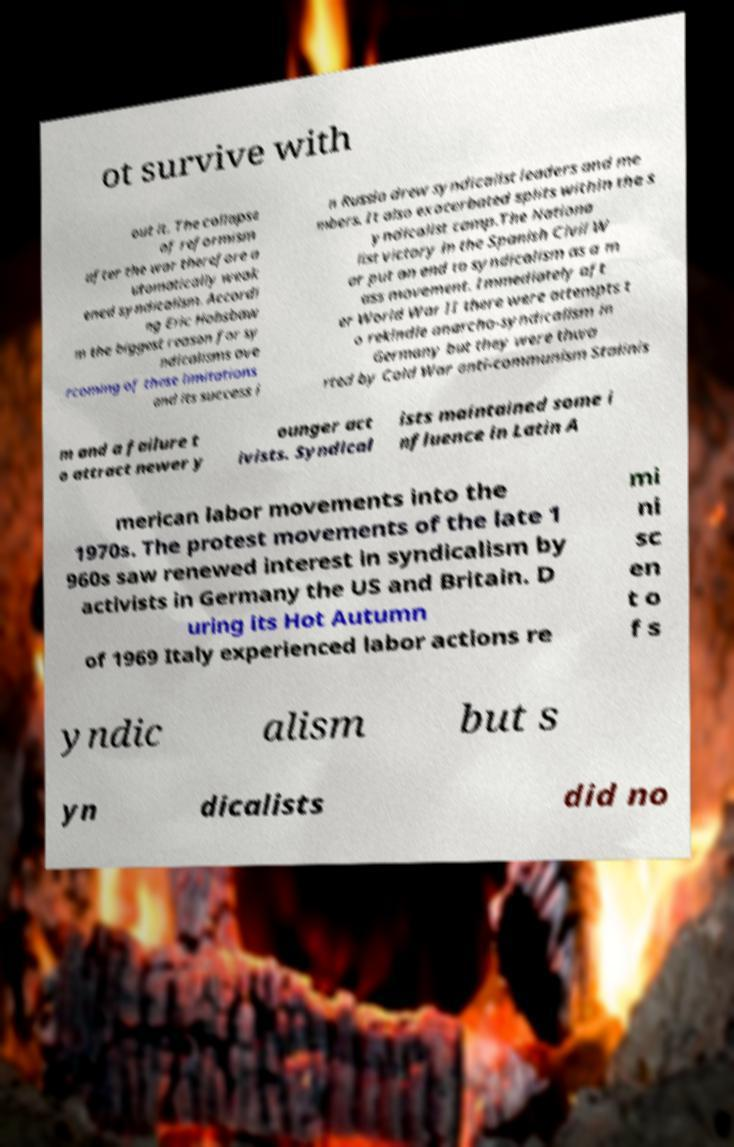There's text embedded in this image that I need extracted. Can you transcribe it verbatim? ot survive with out it. The collapse of reformism after the war therefore a utomatically weak ened syndicalism. Accordi ng Eric Hobsbaw m the biggest reason for sy ndicalisms ove rcoming of these limitations and its success i n Russia drew syndicalist leaders and me mbers. It also exacerbated splits within the s yndicalist camp.The Nationa list victory in the Spanish Civil W ar put an end to syndicalism as a m ass movement. Immediately aft er World War II there were attempts t o rekindle anarcho-syndicalism in Germany but they were thwa rted by Cold War anti-communism Stalinis m and a failure t o attract newer y ounger act ivists. Syndical ists maintained some i nfluence in Latin A merican labor movements into the 1970s. The protest movements of the late 1 960s saw renewed interest in syndicalism by activists in Germany the US and Britain. D uring its Hot Autumn of 1969 Italy experienced labor actions re mi ni sc en t o f s yndic alism but s yn dicalists did no 